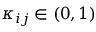<formula> <loc_0><loc_0><loc_500><loc_500>\kappa _ { i j } \in ( 0 , 1 )</formula> 